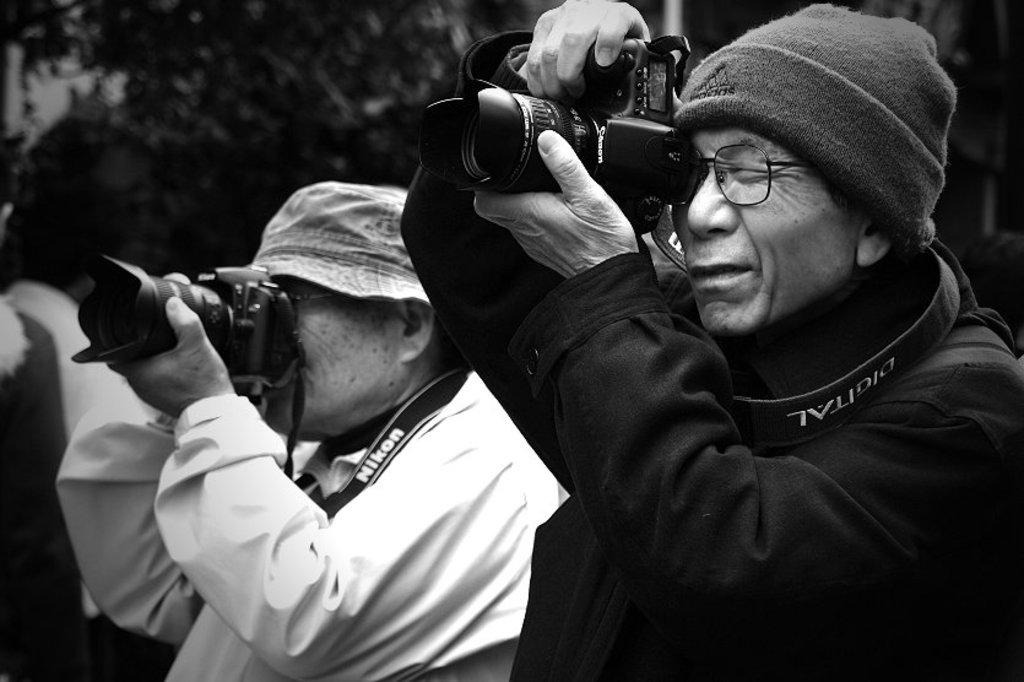How many people are in the image? There are two men in the image. What are the men doing in the image? The men are standing in the image. What objects are the men holding in their hands? The men are holding cameras in their hands. What type of industry is depicted in the image? There is no specific industry depicted in the image; it features two men holding cameras. Where is the club located in the image? There is no club present in the image. 